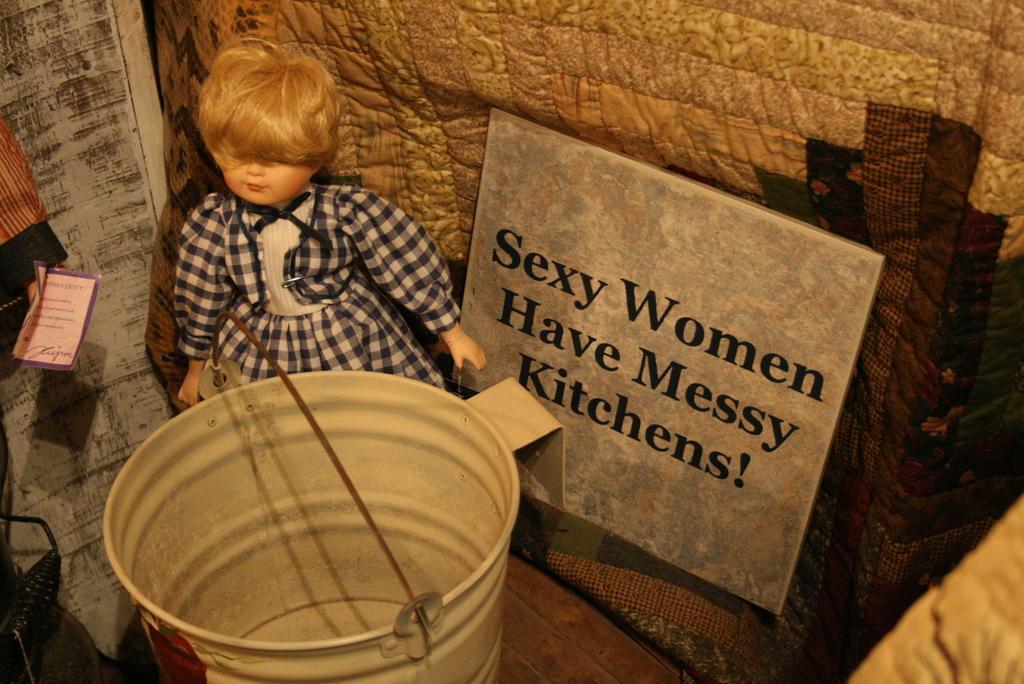Describe this image in one or two sentences. In this image we can see doll, bucket, name board, wooden wall. 